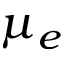Convert formula to latex. <formula><loc_0><loc_0><loc_500><loc_500>\mu _ { e }</formula> 